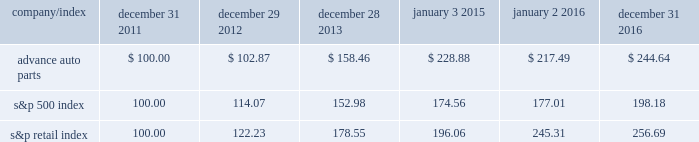Stock price performance the following graph shows a comparison of the cumulative total return on our common stock , the standard & poor 2019s 500 index and the standard & poor 2019s retail index .
The graph assumes that the value of an investment in our common stock and in each such index was $ 100 on december 31 , 2011 , and that any dividends have been reinvested .
The comparison in the graph below is based solely on historical data and is not intended to forecast the possible future performance of our common stock .
Comparison of cumulative total return among advance auto parts , inc. , s&p 500 index and s&p retail index company/index december 31 , december 29 , december 28 , january 3 , january 2 , december 31 .

From january 3 2015 to december 31 , how much greater was the return for s&p retail index than for advance auto parts ? ( in a percentage )? 
Rationale: to find how much greater a return was for the s&p retail index one must find the percentage gain for each company and then compare these percentage gains .
Computations: (((256.69 - 196.06) / 196.06) - ((244.64 - 228.88) / 228.88))
Answer: 0.24039. 